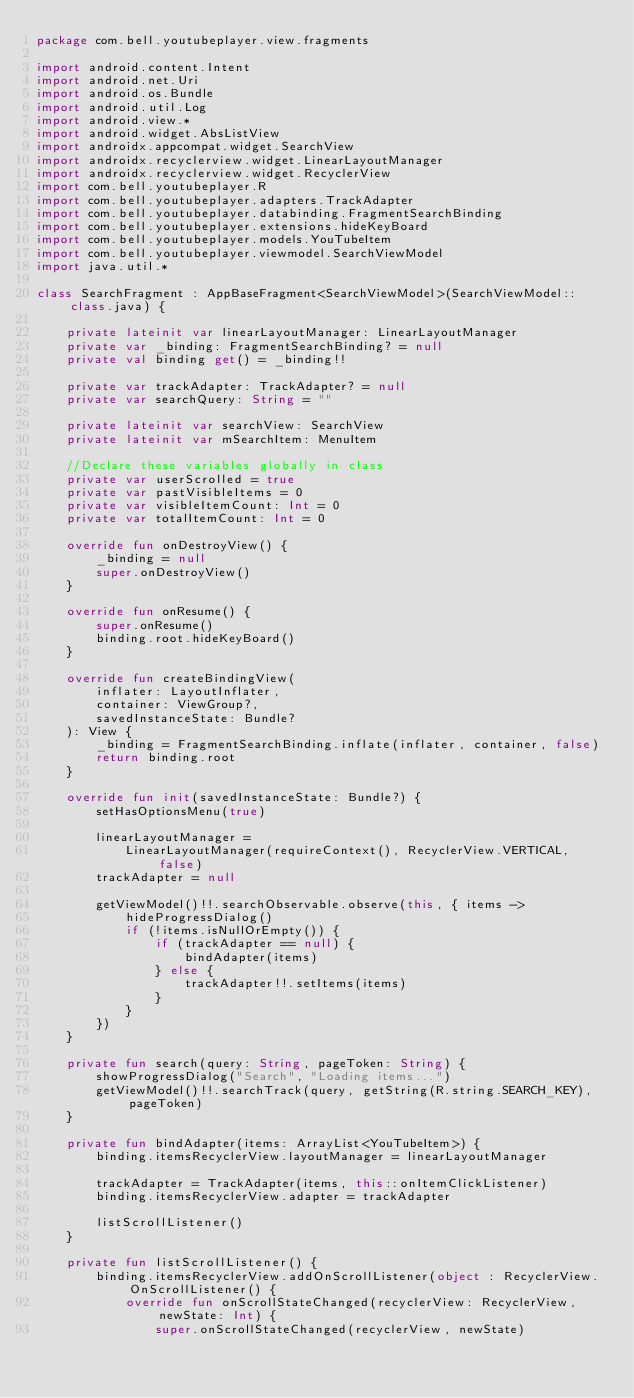<code> <loc_0><loc_0><loc_500><loc_500><_Kotlin_>package com.bell.youtubeplayer.view.fragments

import android.content.Intent
import android.net.Uri
import android.os.Bundle
import android.util.Log
import android.view.*
import android.widget.AbsListView
import androidx.appcompat.widget.SearchView
import androidx.recyclerview.widget.LinearLayoutManager
import androidx.recyclerview.widget.RecyclerView
import com.bell.youtubeplayer.R
import com.bell.youtubeplayer.adapters.TrackAdapter
import com.bell.youtubeplayer.databinding.FragmentSearchBinding
import com.bell.youtubeplayer.extensions.hideKeyBoard
import com.bell.youtubeplayer.models.YouTubeItem
import com.bell.youtubeplayer.viewmodel.SearchViewModel
import java.util.*

class SearchFragment : AppBaseFragment<SearchViewModel>(SearchViewModel::class.java) {

    private lateinit var linearLayoutManager: LinearLayoutManager
    private var _binding: FragmentSearchBinding? = null
    private val binding get() = _binding!!

    private var trackAdapter: TrackAdapter? = null
    private var searchQuery: String = ""

    private lateinit var searchView: SearchView
    private lateinit var mSearchItem: MenuItem

    //Declare these variables globally in class
    private var userScrolled = true
    private var pastVisibleItems = 0
    private var visibleItemCount: Int = 0
    private var totalItemCount: Int = 0

    override fun onDestroyView() {
        _binding = null
        super.onDestroyView()
    }

    override fun onResume() {
        super.onResume()
        binding.root.hideKeyBoard()
    }

    override fun createBindingView(
        inflater: LayoutInflater,
        container: ViewGroup?,
        savedInstanceState: Bundle?
    ): View {
        _binding = FragmentSearchBinding.inflate(inflater, container, false)
        return binding.root
    }

    override fun init(savedInstanceState: Bundle?) {
        setHasOptionsMenu(true)

        linearLayoutManager =
            LinearLayoutManager(requireContext(), RecyclerView.VERTICAL, false)
        trackAdapter = null

        getViewModel()!!.searchObservable.observe(this, { items ->
            hideProgressDialog()
            if (!items.isNullOrEmpty()) {
                if (trackAdapter == null) {
                    bindAdapter(items)
                } else {
                    trackAdapter!!.setItems(items)
                }
            }
        })
    }

    private fun search(query: String, pageToken: String) {
        showProgressDialog("Search", "Loading items...")
        getViewModel()!!.searchTrack(query, getString(R.string.SEARCH_KEY), pageToken)
    }

    private fun bindAdapter(items: ArrayList<YouTubeItem>) {
        binding.itemsRecyclerView.layoutManager = linearLayoutManager

        trackAdapter = TrackAdapter(items, this::onItemClickListener)
        binding.itemsRecyclerView.adapter = trackAdapter

        listScrollListener()
    }

    private fun listScrollListener() {
        binding.itemsRecyclerView.addOnScrollListener(object : RecyclerView.OnScrollListener() {
            override fun onScrollStateChanged(recyclerView: RecyclerView, newState: Int) {
                super.onScrollStateChanged(recyclerView, newState)</code> 